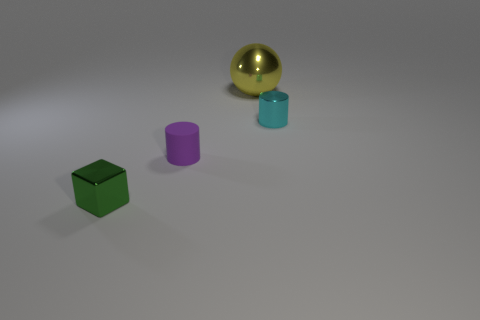Add 4 tiny cubes. How many objects exist? 8 Subtract all cubes. How many objects are left? 3 Subtract all cyan objects. Subtract all large yellow spheres. How many objects are left? 2 Add 3 big things. How many big things are left? 4 Add 4 small red cylinders. How many small red cylinders exist? 4 Subtract 0 brown balls. How many objects are left? 4 